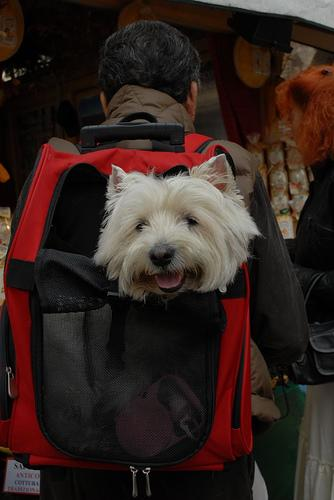Briefly describe the appearance of the woman in the image. The woman in the image has red hair and appears to be wearing a lace white skirt. Describe any accessories or unique features of the backpack in the image. The backpack has black netting on one side, two silver zipper pulls, a black handle, and a pink leash inside. Examine the dog's facial features closely. Describe its eyes, ears, and mouth. The dog has black eyes that are mostly covered by hair, ears on its head, and an open mouth with a pink tongue. Provide a short and concise description of the image's focal point. A man carrying a backpack with a white dog inside, looking out from the bag. Analyze the overall sentiment of the image. Is it happy, sad, or neutral? Explain your answer. The overall sentiment of the image is happy, as the dog appears content and the man and woman seem to be enjoying their time together. What is the relationship between the man and the dog in the image? The man is carrying the dog inside his backpack, implying the dog is his pet and they are traveling together. How does the dog in the image appear to be feeling? Explain your reasoning. The dog seems to be content and curious, as it is sticking its tongue out and looking out from the backpack. Identify the color and pattern of the backpack in the image. The backpack is red and black with black netting on the side. Can you count the number of people in the image? Provide a brief description of one of them. There are two people in the image. One of them is a man wearing a red and black backpack with a white dog inside. What type of animal is in the picture, and where is it located? A white long-haired dog is in the picture, and it is located inside a red and black backpack. Where are the golden zipper pulls on the bag? The zippers are silver, not golden. This instruction is misleading as it directs people to look for golden zipper pulls that don't exist in the image. Can you find the black dog in the image? The dog in the image is white, not black. This instruction can mislead people to look for a black dog, which is not present in the image. Where is the dog with the yellow tongue? The dog's tongue is pink, not yellow. This instruction can create confusion as people search for a dog with a yellow tongue, which doesn't exist in the image. Where is the blue backpack with the dog inside? The backpack is red and black, not blue. This instruction can lead people to search for a different colored backpack and create confusion. Can you see a man wearing a blue jacket? The man is wearing a brown vest, not a blue jacket. This instruction is misleading because it suggests looking for a man wearing a blue jacket, which is not present in the image. Can you spot the woman with the green hair? The woman in the image has red hair, not green. This instruction would cause confusion as people might search for a woman with green hair, which doesn't exist in the image. 